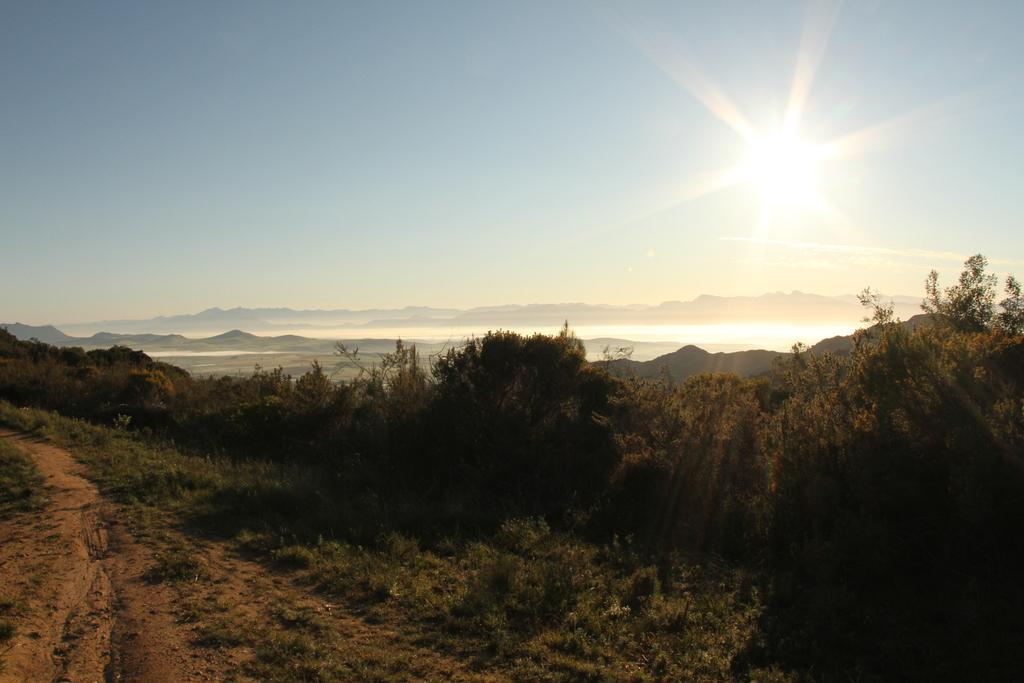Could you give a brief overview of what you see in this image? This picture is clicked in the outskirts. At the bottom of the picture, we see grass and sand. Beside that, there are many trees and behind that, we see water. There are many hills in the background. At the top of the picture, we see the sky and the sun. 